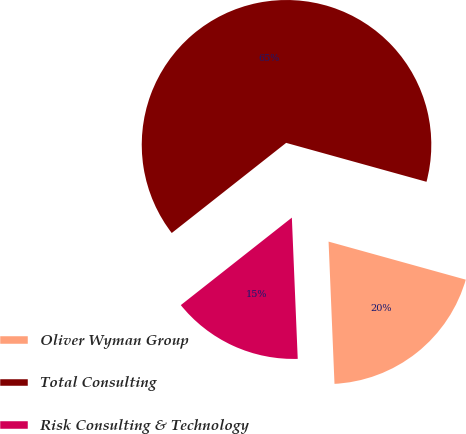<chart> <loc_0><loc_0><loc_500><loc_500><pie_chart><fcel>Oliver Wyman Group<fcel>Total Consulting<fcel>Risk Consulting & Technology<nl><fcel>20.03%<fcel>64.92%<fcel>15.04%<nl></chart> 